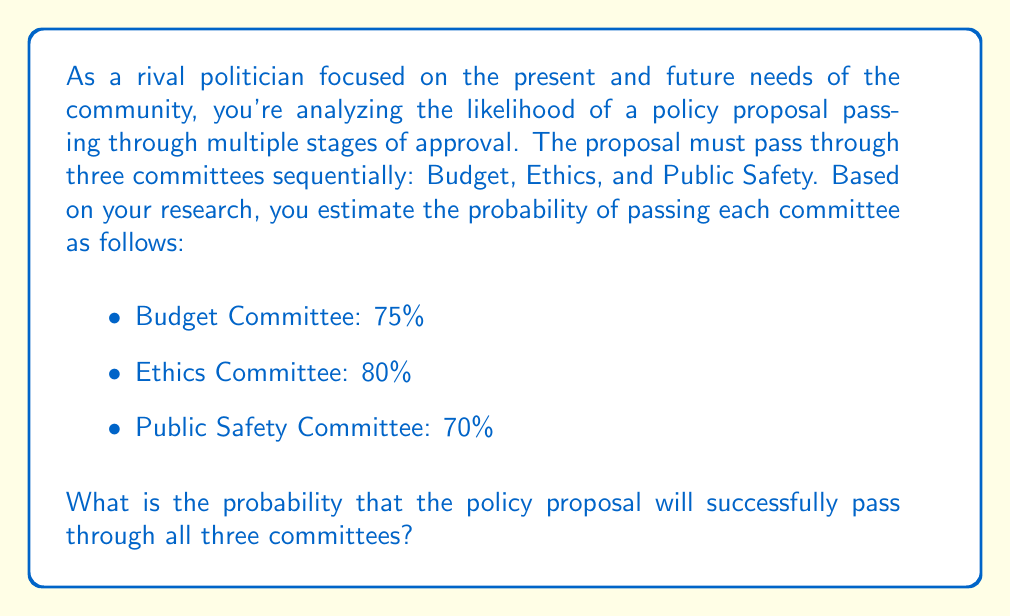Give your solution to this math problem. To solve this problem, we need to consider the concept of independent events in probability theory. Since the proposal must pass through all three committees sequentially, we need to calculate the probability of all three events occurring together.

For independent events, the probability of all events occurring is the product of their individual probabilities.

Let's define the events:
$A$: Passing the Budget Committee
$B$: Passing the Ethics Committee
$C$: Passing the Public Safety Committee

We want to find $P(A \cap B \cap C)$, which is the probability of all three events occurring.

Given:
$P(A) = 0.75$
$P(B) = 0.80$
$P(C) = 0.70$

For independent events:
$$P(A \cap B \cap C) = P(A) \times P(B) \times P(C)$$

Substituting the values:

$$P(A \cap B \cap C) = 0.75 \times 0.80 \times 0.70$$

Calculating:
$$P(A \cap B \cap C) = 0.42$$

To express this as a percentage:
$$0.42 \times 100\% = 42\%$$

Therefore, the probability that the policy proposal will successfully pass through all three committees is 42%.
Answer: The probability that the policy proposal will successfully pass through all three committees is 42%. 